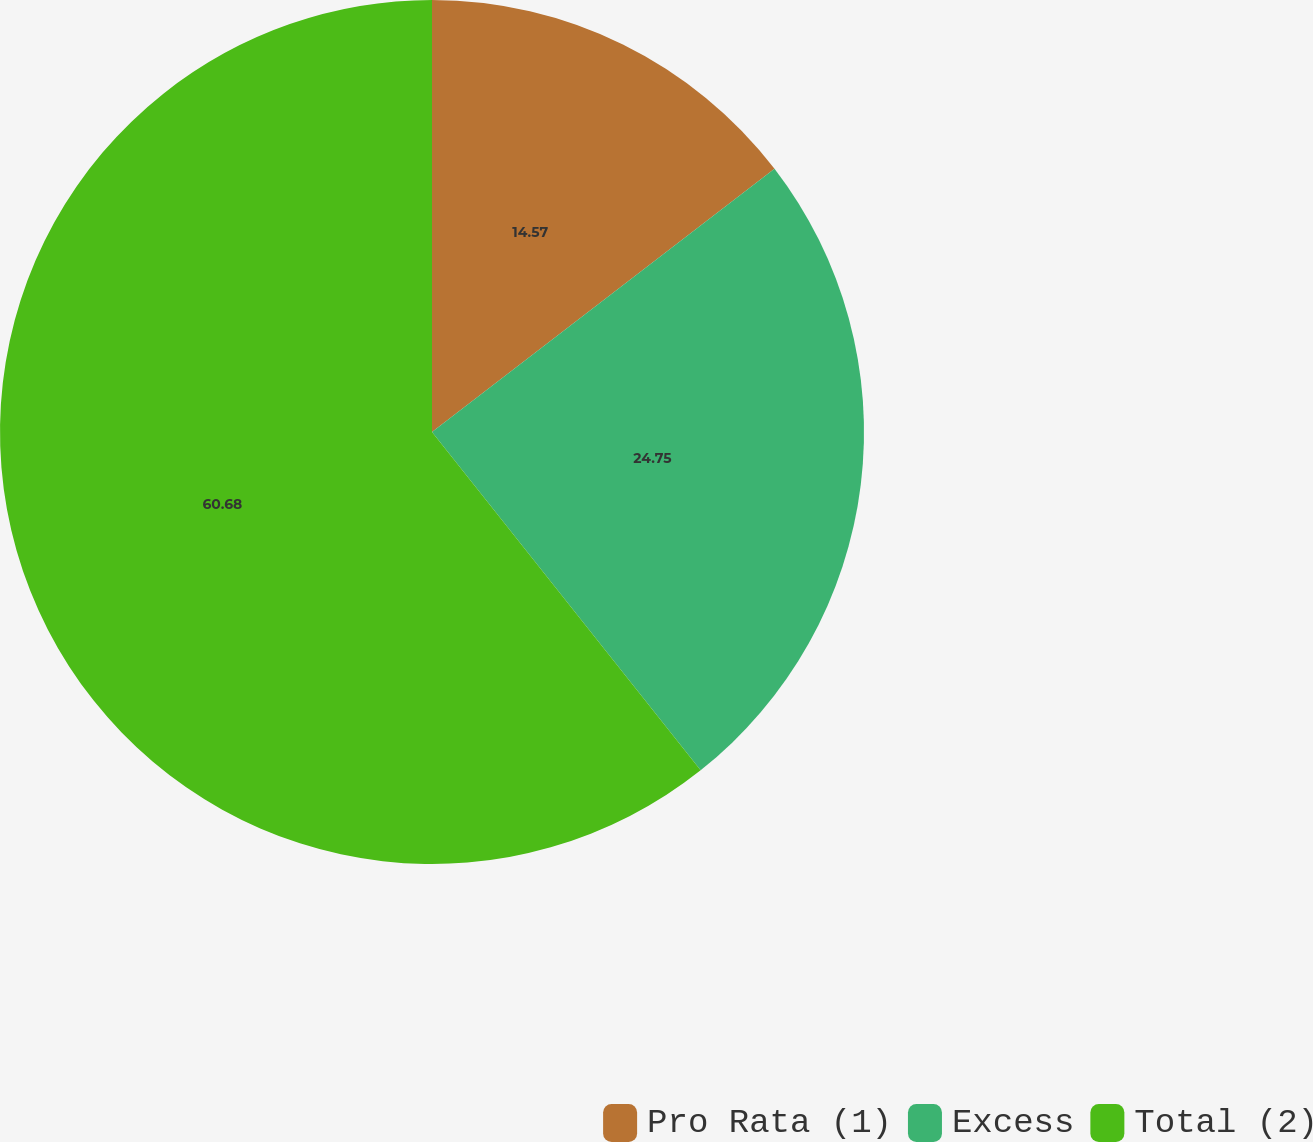Convert chart to OTSL. <chart><loc_0><loc_0><loc_500><loc_500><pie_chart><fcel>Pro Rata (1)<fcel>Excess<fcel>Total (2)<nl><fcel>14.57%<fcel>24.75%<fcel>60.68%<nl></chart> 